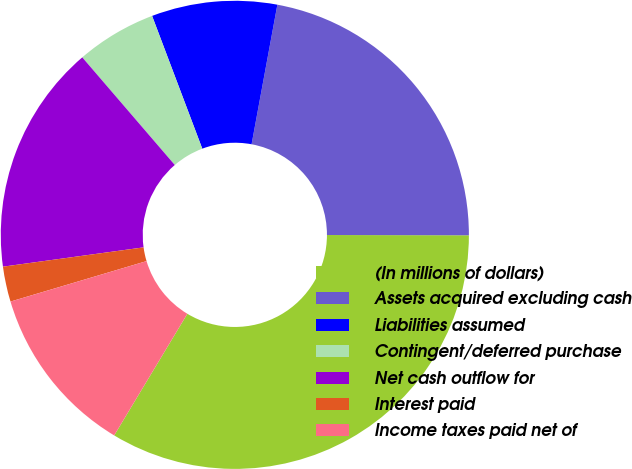Convert chart to OTSL. <chart><loc_0><loc_0><loc_500><loc_500><pie_chart><fcel>(In millions of dollars)<fcel>Assets acquired excluding cash<fcel>Liabilities assumed<fcel>Contingent/deferred purchase<fcel>Net cash outflow for<fcel>Interest paid<fcel>Income taxes paid net of<nl><fcel>33.59%<fcel>22.12%<fcel>8.66%<fcel>5.55%<fcel>15.87%<fcel>2.43%<fcel>11.78%<nl></chart> 